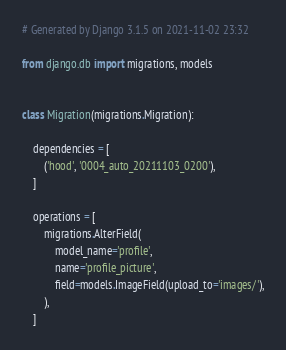Convert code to text. <code><loc_0><loc_0><loc_500><loc_500><_Python_># Generated by Django 3.1.5 on 2021-11-02 23:32

from django.db import migrations, models


class Migration(migrations.Migration):

    dependencies = [
        ('hood', '0004_auto_20211103_0200'),
    ]

    operations = [
        migrations.AlterField(
            model_name='profile',
            name='profile_picture',
            field=models.ImageField(upload_to='images/'),
        ),
    ]
</code> 